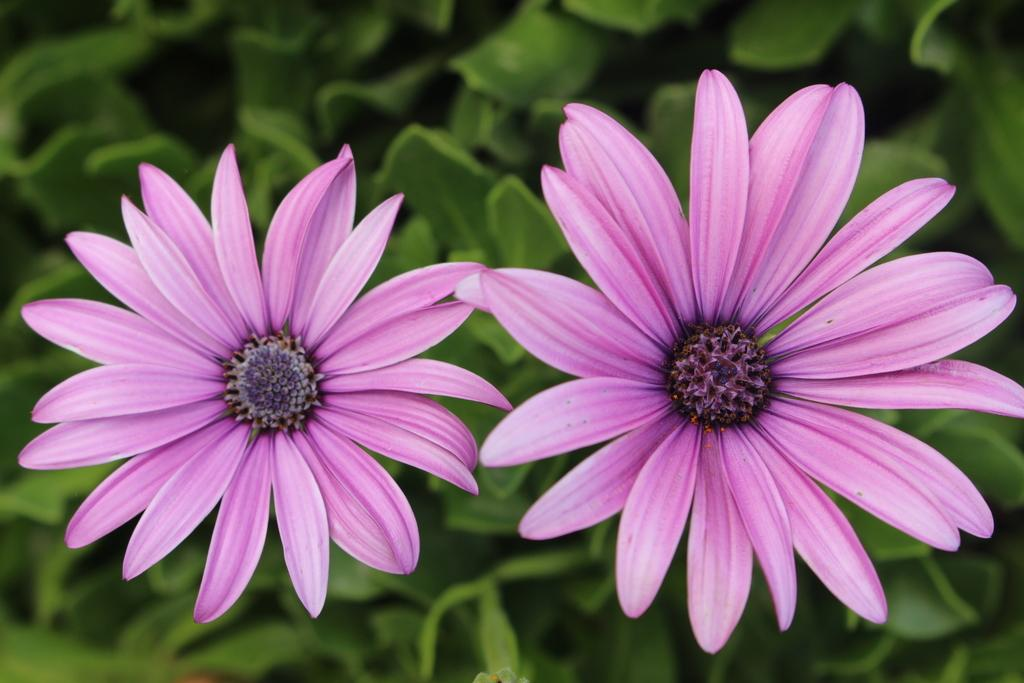What type of plants can be seen in the image? There are flowers in the image. What can be seen in the background of the image? There are leaves in the background of the image. What type of toy is being used to knit wool in the image? There is no toy or wool present in the image; it only features flowers and leaves. 